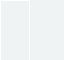<code> <loc_0><loc_0><loc_500><loc_500><_Haskell_>

	
	


</code> 